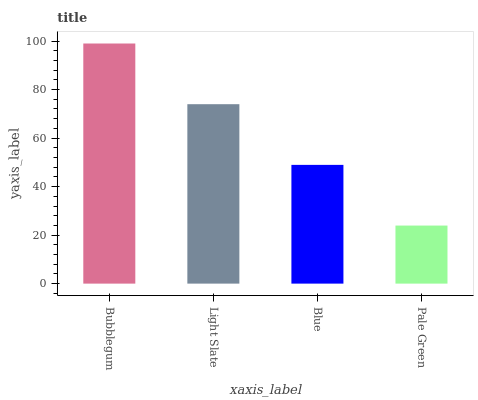Is Pale Green the minimum?
Answer yes or no. Yes. Is Bubblegum the maximum?
Answer yes or no. Yes. Is Light Slate the minimum?
Answer yes or no. No. Is Light Slate the maximum?
Answer yes or no. No. Is Bubblegum greater than Light Slate?
Answer yes or no. Yes. Is Light Slate less than Bubblegum?
Answer yes or no. Yes. Is Light Slate greater than Bubblegum?
Answer yes or no. No. Is Bubblegum less than Light Slate?
Answer yes or no. No. Is Light Slate the high median?
Answer yes or no. Yes. Is Blue the low median?
Answer yes or no. Yes. Is Bubblegum the high median?
Answer yes or no. No. Is Pale Green the low median?
Answer yes or no. No. 